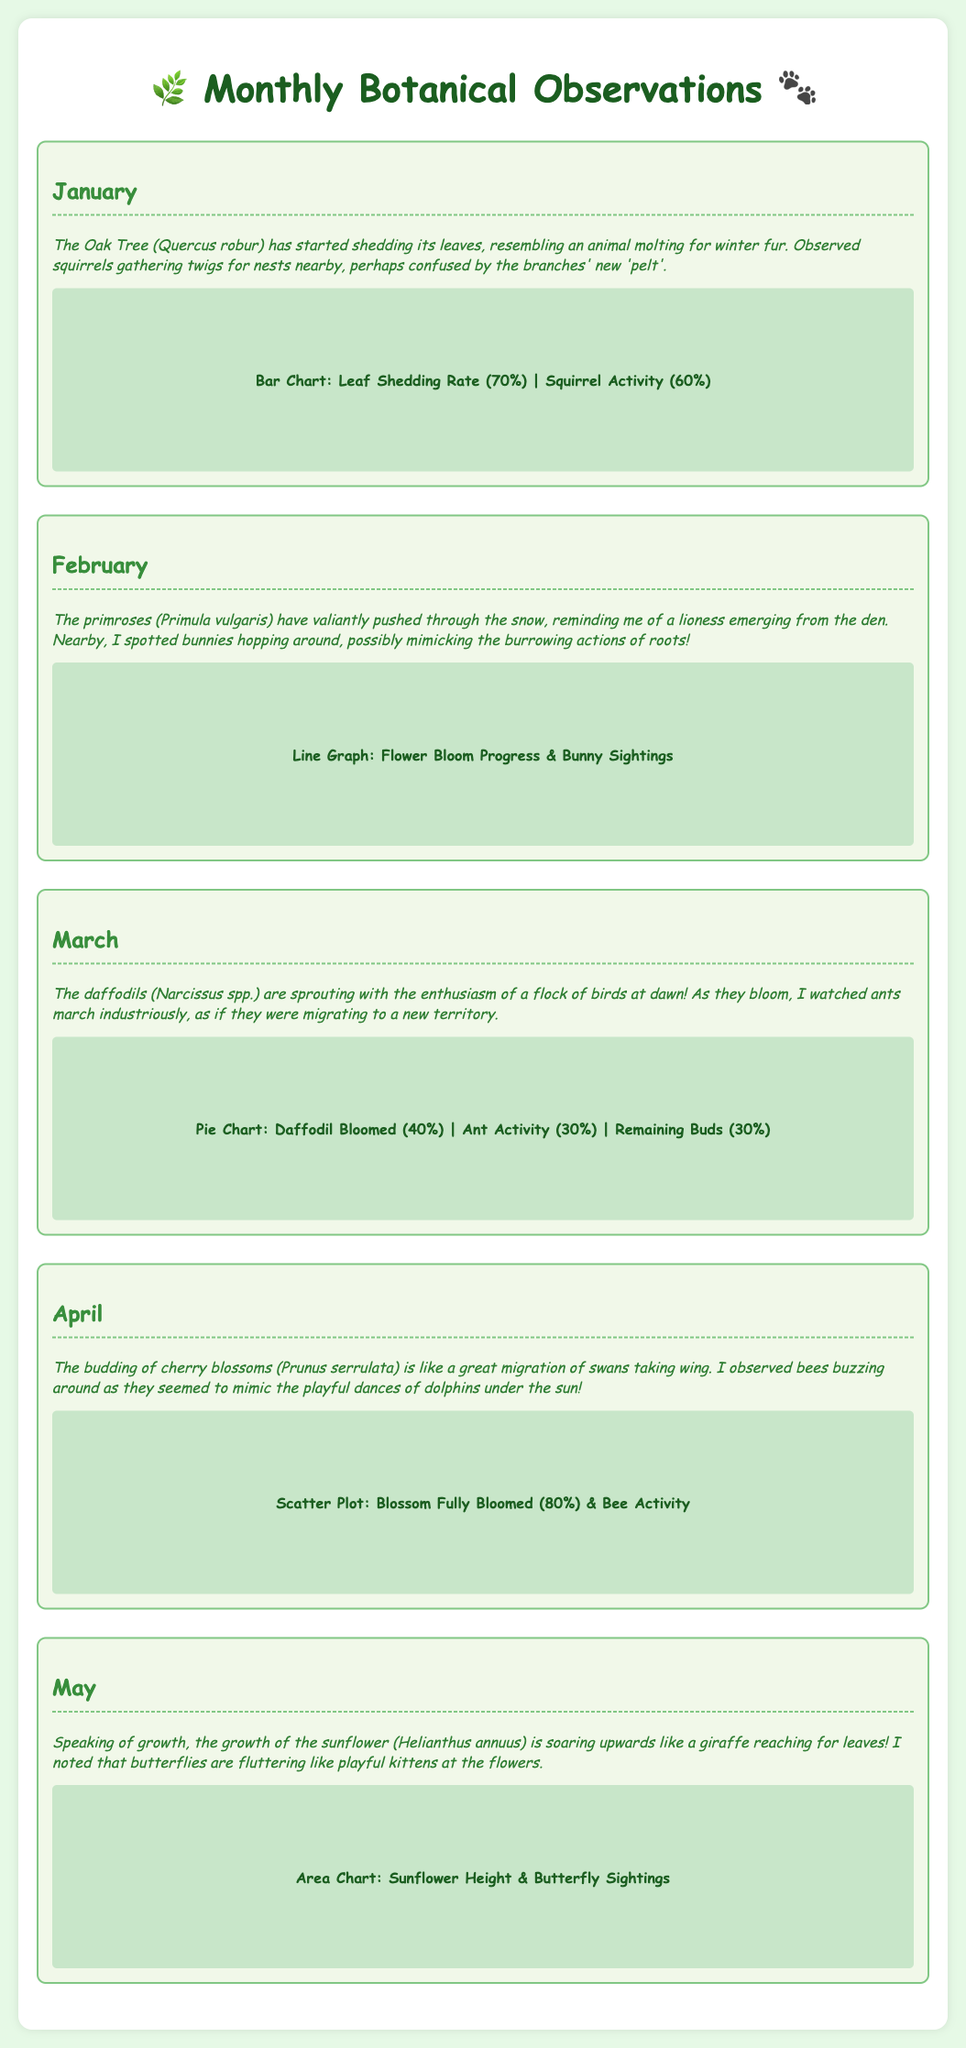what is the first plant mentioned in January? The first plant mentioned in January is the Oak Tree, which is noted for shedding leaves.
Answer: Oak Tree how much leaf shedding rate is observed in January? The document states the leaf shedding rate in January is 70%.
Answer: 70% what animal behavior is noted in February? The animal behavior noted in February involves bunnies hopping around, possibly mimicking burrowing actions.
Answer: bunnies hopping in which month do daffodils bloom with enthusiasm? Daffodils bloom with enthusiasm in March, as described in the observations.
Answer: March what is the percentage of blossoms fully bloomed in April? In April, the percentage of blossoms fully bloomed is 80%.
Answer: 80% which animal is observed fluttering around sunflowers in May? The animal observed fluttering around sunflowers in May is butterflies.
Answer: butterflies how do cherry blossoms' budding compare to animal migration? The budding of cherry blossoms is compared to a great migration of swans taking wing.
Answer: swans what is the chart type displaying daffodil activity in March? The chart type displaying daffodil activity in March is a Pie Chart.
Answer: Pie Chart which flowering plant is associated with the illustration of playful kittens? The flowering plant associated with the illustration of playful kittens is the sunflower.
Answer: sunflower 